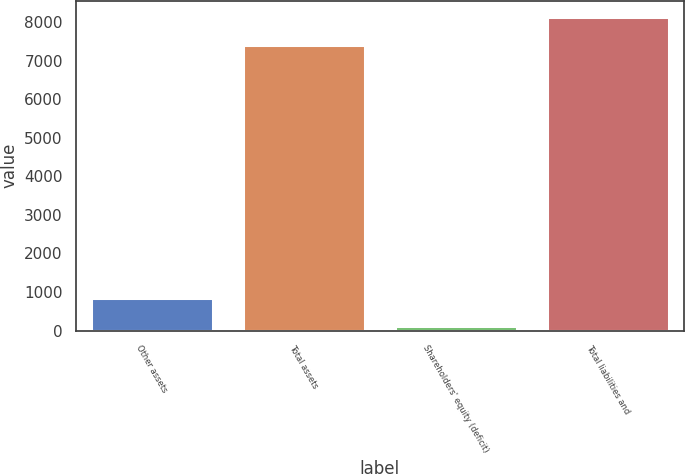<chart> <loc_0><loc_0><loc_500><loc_500><bar_chart><fcel>Other assets<fcel>Total assets<fcel>Shareholders' equity (deficit)<fcel>Total liabilities and<nl><fcel>841.8<fcel>7410<fcel>112<fcel>8139.8<nl></chart> 